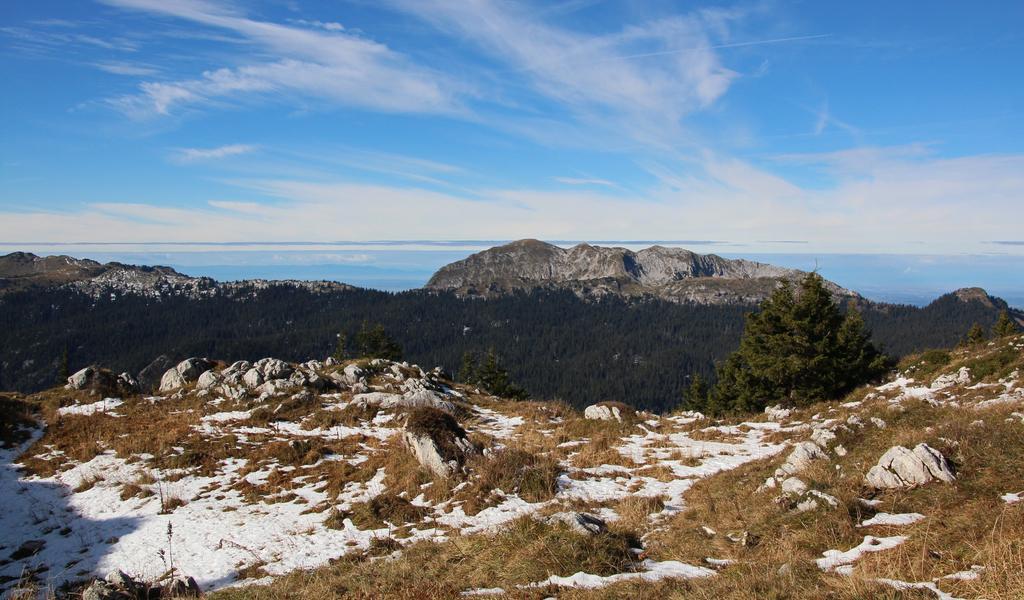Describe this image in one or two sentences. As we can see in the image there is snow, dry grass, trees, hills, sky and clouds. 